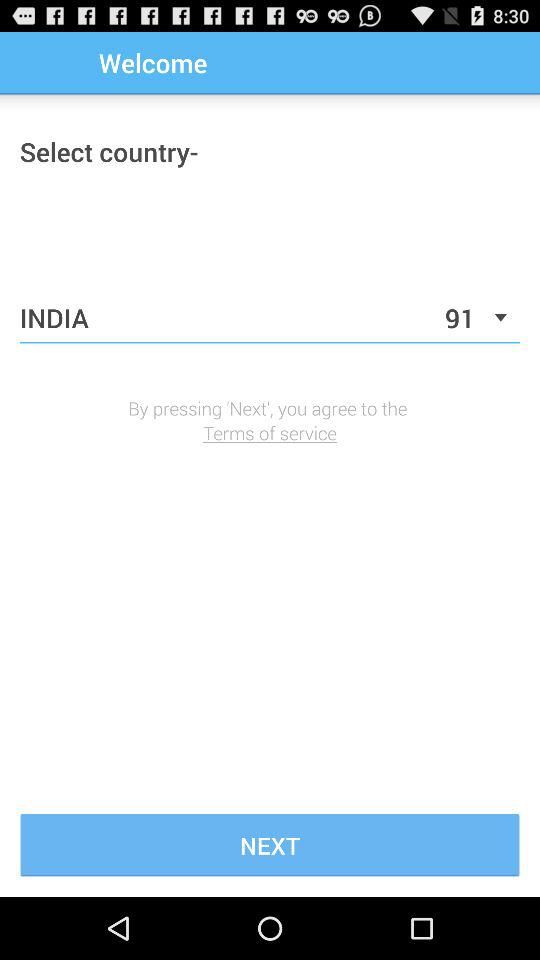Has the user agreed to the terms of service?
When the provided information is insufficient, respond with <no answer>. <no answer> 